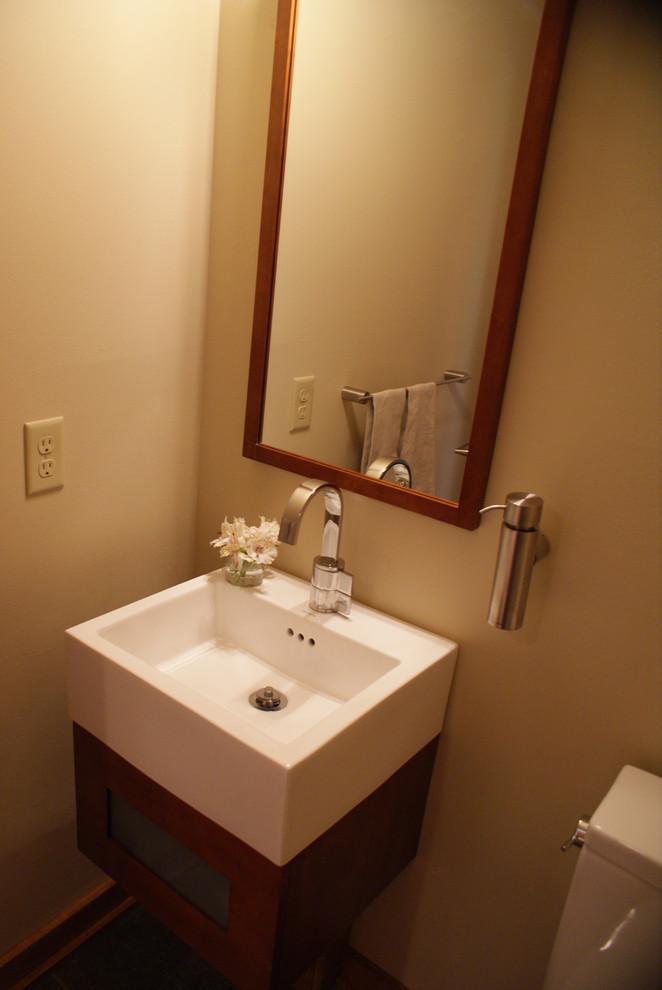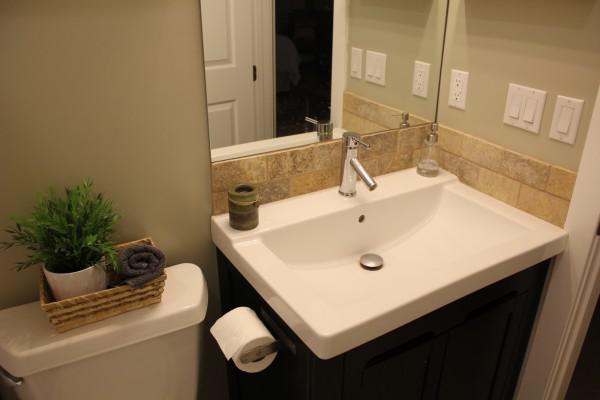The first image is the image on the left, the second image is the image on the right. For the images shown, is this caption "there is a white square shaped sink with a chrome faucet and a vase of flowers next to it" true? Answer yes or no. Yes. The first image is the image on the left, the second image is the image on the right. Evaluate the accuracy of this statement regarding the images: "The left and right image contains a total of two white square sinks.". Is it true? Answer yes or no. Yes. 